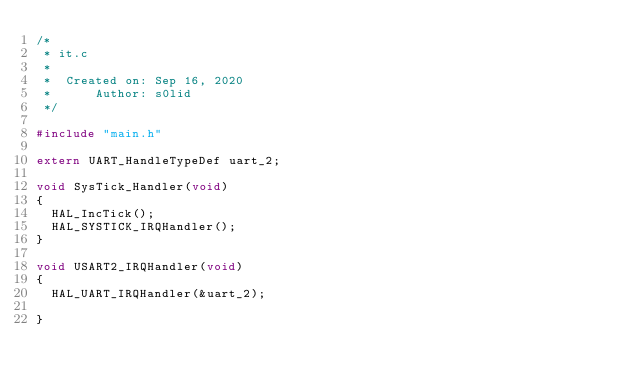Convert code to text. <code><loc_0><loc_0><loc_500><loc_500><_C_>/*
 * it.c
 *
 *  Created on: Sep 16, 2020
 *      Author: s0lid
 */

#include "main.h"

extern UART_HandleTypeDef uart_2;

void SysTick_Handler(void)
{
	HAL_IncTick();
	HAL_SYSTICK_IRQHandler();
}

void USART2_IRQHandler(void)
{
	HAL_UART_IRQHandler(&uart_2);

}
</code> 